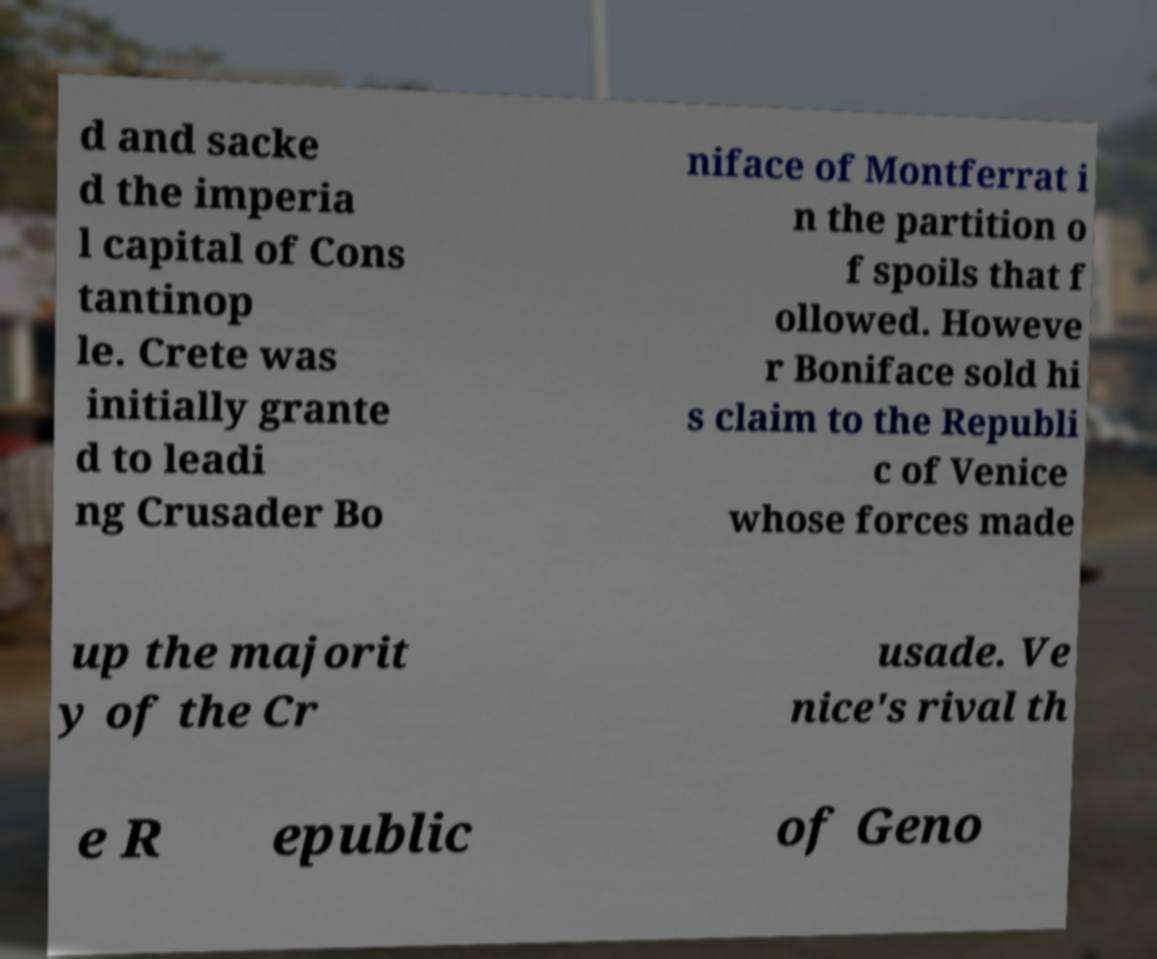Please read and relay the text visible in this image. What does it say? d and sacke d the imperia l capital of Cons tantinop le. Crete was initially grante d to leadi ng Crusader Bo niface of Montferrat i n the partition o f spoils that f ollowed. Howeve r Boniface sold hi s claim to the Republi c of Venice whose forces made up the majorit y of the Cr usade. Ve nice's rival th e R epublic of Geno 